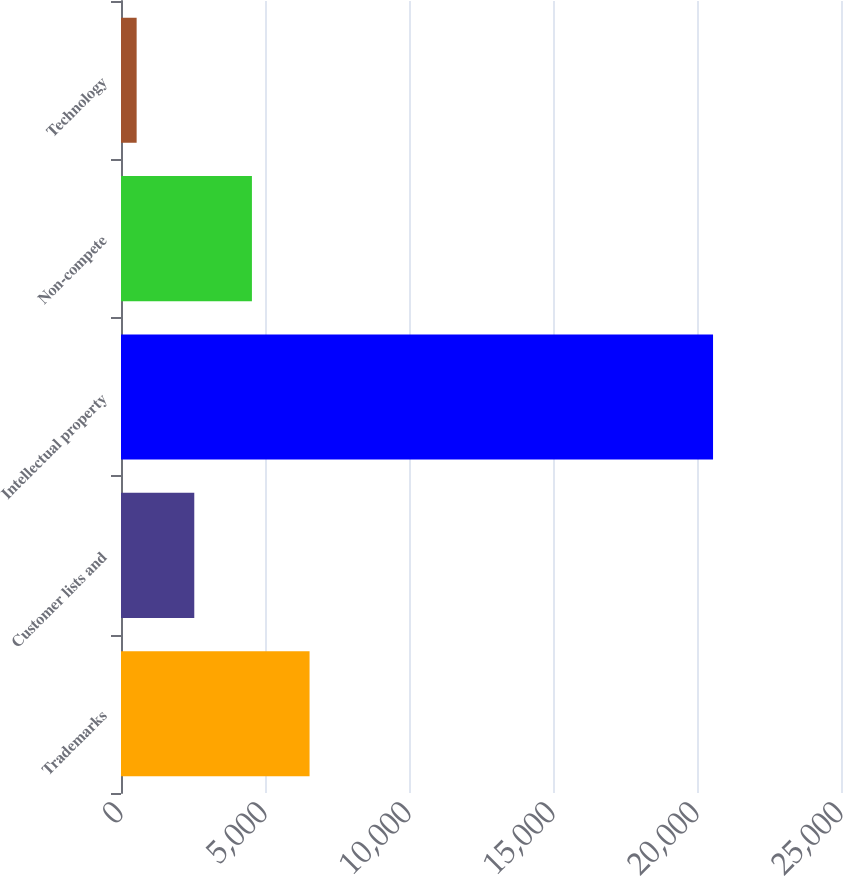<chart> <loc_0><loc_0><loc_500><loc_500><bar_chart><fcel>Trademarks<fcel>Customer lists and<fcel>Intellectual property<fcel>Non-compete<fcel>Technology<nl><fcel>6547.2<fcel>2544.4<fcel>20557<fcel>4545.8<fcel>543<nl></chart> 